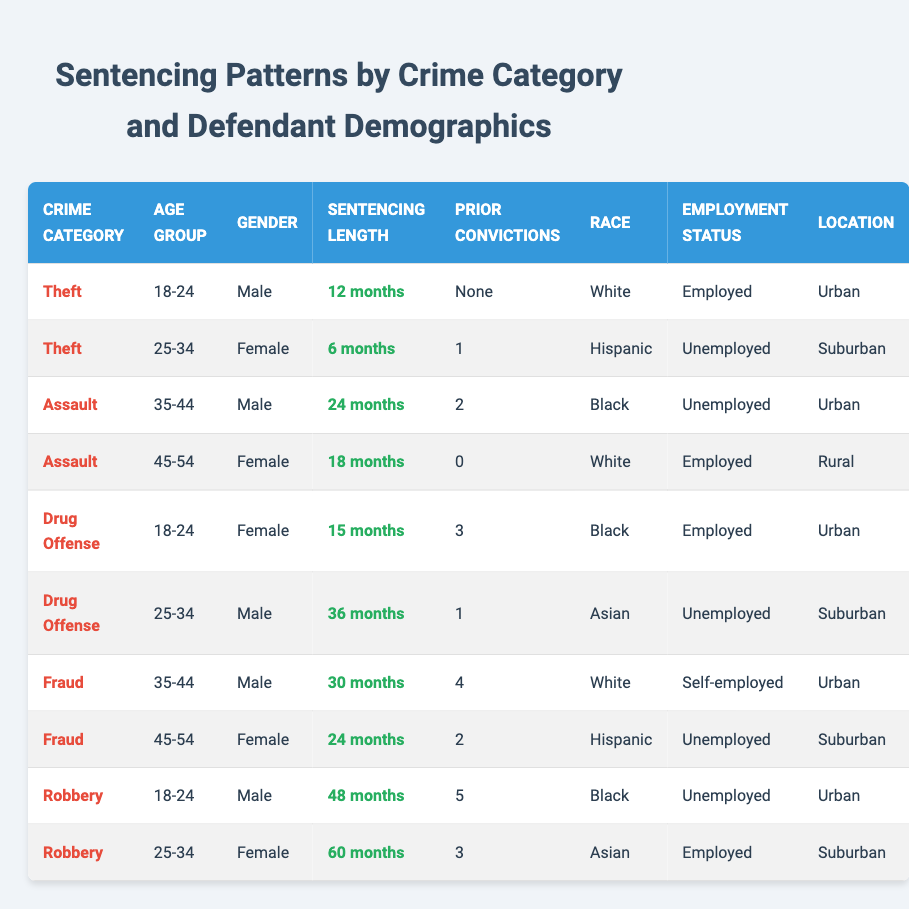What is the sentencing length for Theft committed by a Male aged 18-24? In the table, there is a row that identifies the sentencing length for Theft when the defendant's age group is 18-24 and the gender is Male. This sentencing length is listed as 12 months.
Answer: 12 months How many prior convictions did the Female defendant aged 45-54 have for Assault? By looking at the table, I can see the row for Assault corresponding to the Female age group of 45-54. In that row, the number of prior convictions is noted as 0.
Answer: 0 What is the average sentencing length for Drug Offenses? There are two records for Drug Offense, with sentencing lengths of 15 months and 36 months respectively. I need to calculate the average, which is (15 + 36) / 2 = 51 / 2 = 25.5 months.
Answer: 25.5 months Is there a Male defendant in the age group of 35-44 with 2 prior convictions? Upon checking the records, there is indeed a Male defendant in the age group 35-44 with 2 prior convictions for Assault. Thus, the answer is yes.
Answer: Yes What is the sentencing length for the highest sentencing crime, and which crime category does it belong to? To identify the highest sentencing length, I will review all the entries. The maximum sentencing found is 60 months for the Robbery committed by a Female in the age group of 25-34.
Answer: 60 months, Robbery How many defendants are employed among those convicted for Fraud? In reviewing the table, the Fraud category shows two entries. Only one of them (the Male aged 35-44) is noted as employed. Therefore, there is 1 employed defendant in this category.
Answer: 1 What is the sentencing length difference between the least and most severe sentences in the table? The least severe sentence is 6 months for Theft (25-34, Female) and the most severe is 60 months for Robbery (25-34, Female). The difference is calculated as 60 - 6 = 54 months.
Answer: 54 months Are there any defendants in the table with prior convictions greater than 3? Looking through the table, I find two instances where prior convictions are greater than 3: the Male for Fraud with 4 prior convictions and the Male for Robbery with 5 prior convictions. Therefore, the answer is yes.
Answer: Yes What is the average age group for defendants classified under Drug Offense? There are two records under Drug Offense, 18-24 and 25-34. The average age can be found by taking the midpoint of these ranges: (21 + 29) / 2 = 25. Since these are groups, we'd conclude the average: 25-34 suggests an average grouping of approximately 25.
Answer: 25-34 